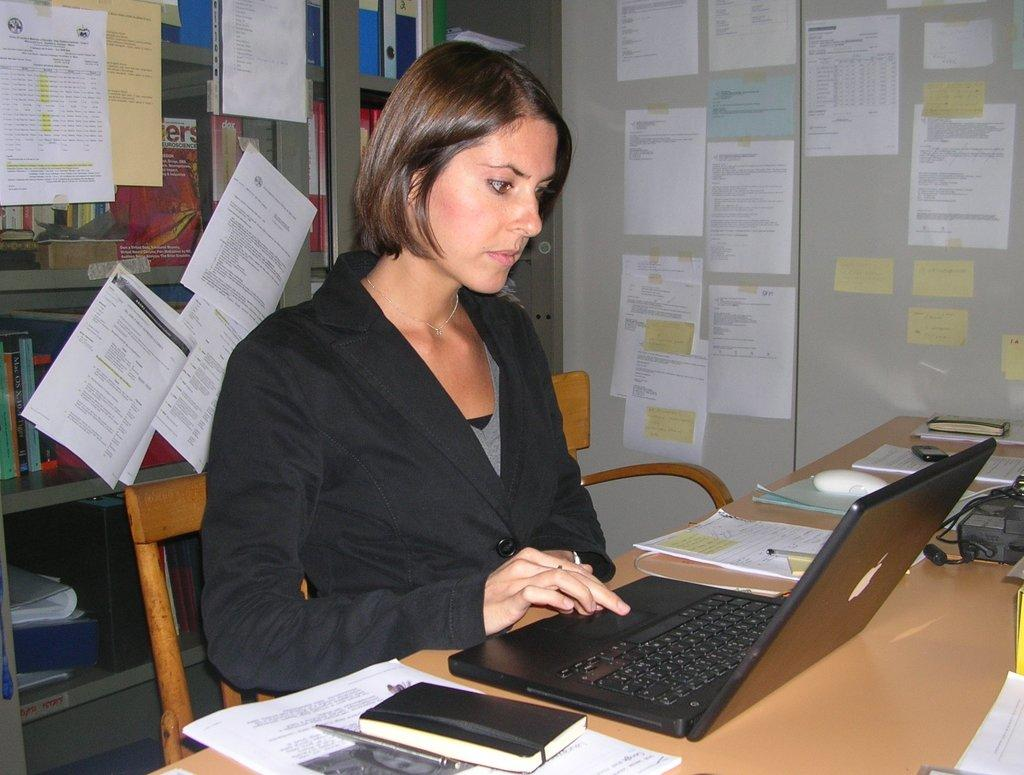<image>
Share a concise interpretation of the image provided. A woman on a laptop with a poster in the background with the word Neuroscience on it. 